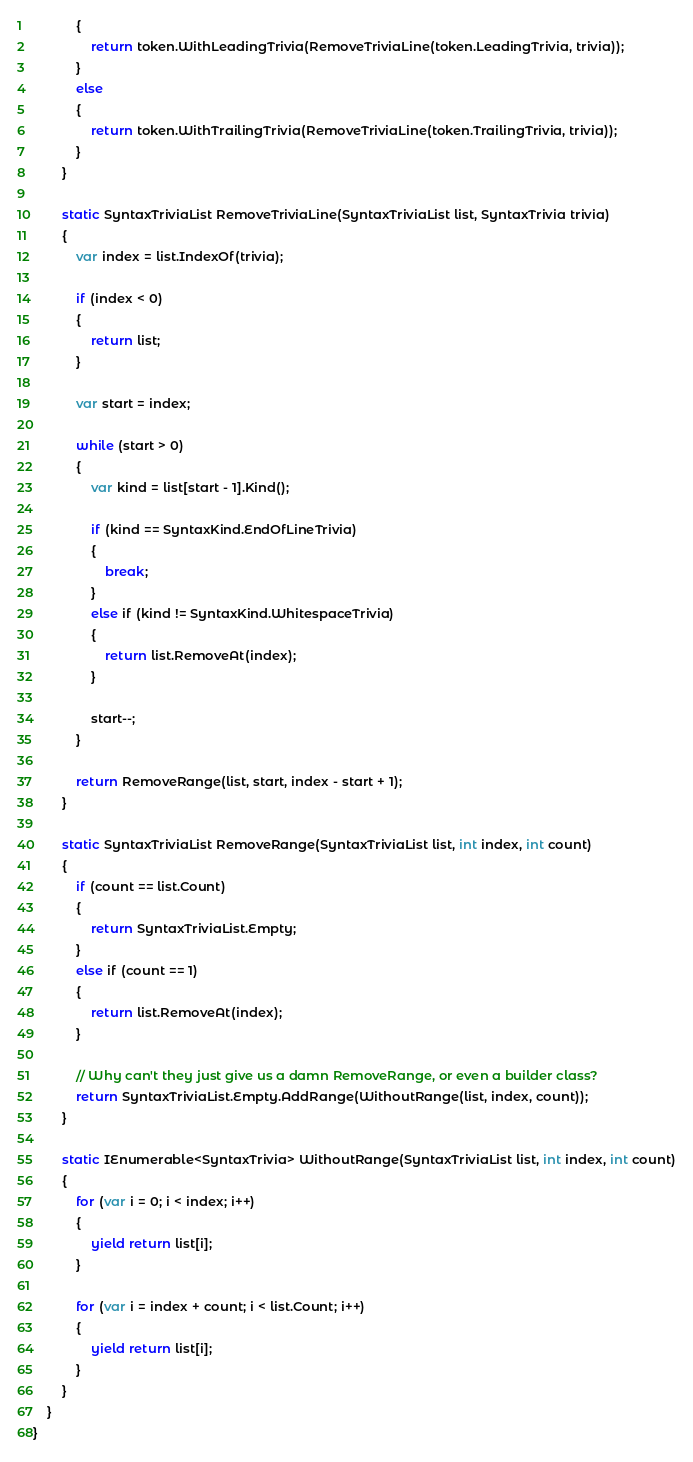Convert code to text. <code><loc_0><loc_0><loc_500><loc_500><_C#_>			{
				return token.WithLeadingTrivia(RemoveTriviaLine(token.LeadingTrivia, trivia));
			}
			else
			{
				return token.WithTrailingTrivia(RemoveTriviaLine(token.TrailingTrivia, trivia));
			}
		}

		static SyntaxTriviaList RemoveTriviaLine(SyntaxTriviaList list, SyntaxTrivia trivia)
		{
			var index = list.IndexOf(trivia);

			if (index < 0)
			{
				return list;
			}

			var start = index;

			while (start > 0)
			{
				var kind = list[start - 1].Kind();

				if (kind == SyntaxKind.EndOfLineTrivia)
				{
					break;
				}
				else if (kind != SyntaxKind.WhitespaceTrivia)
				{
					return list.RemoveAt(index);
				}

				start--;
			}

			return RemoveRange(list, start, index - start + 1);
		}

		static SyntaxTriviaList RemoveRange(SyntaxTriviaList list, int index, int count)
		{
			if (count == list.Count)
			{
				return SyntaxTriviaList.Empty;
			}
			else if (count == 1)
			{
				return list.RemoveAt(index);
			}

			// Why can't they just give us a damn RemoveRange, or even a builder class?
			return SyntaxTriviaList.Empty.AddRange(WithoutRange(list, index, count));
		}

		static IEnumerable<SyntaxTrivia> WithoutRange(SyntaxTriviaList list, int index, int count)
		{
			for (var i = 0; i < index; i++)
			{
				yield return list[i];
			}

			for (var i = index + count; i < list.Count; i++)
			{
				yield return list[i];
			}
		}
	}
}
</code> 